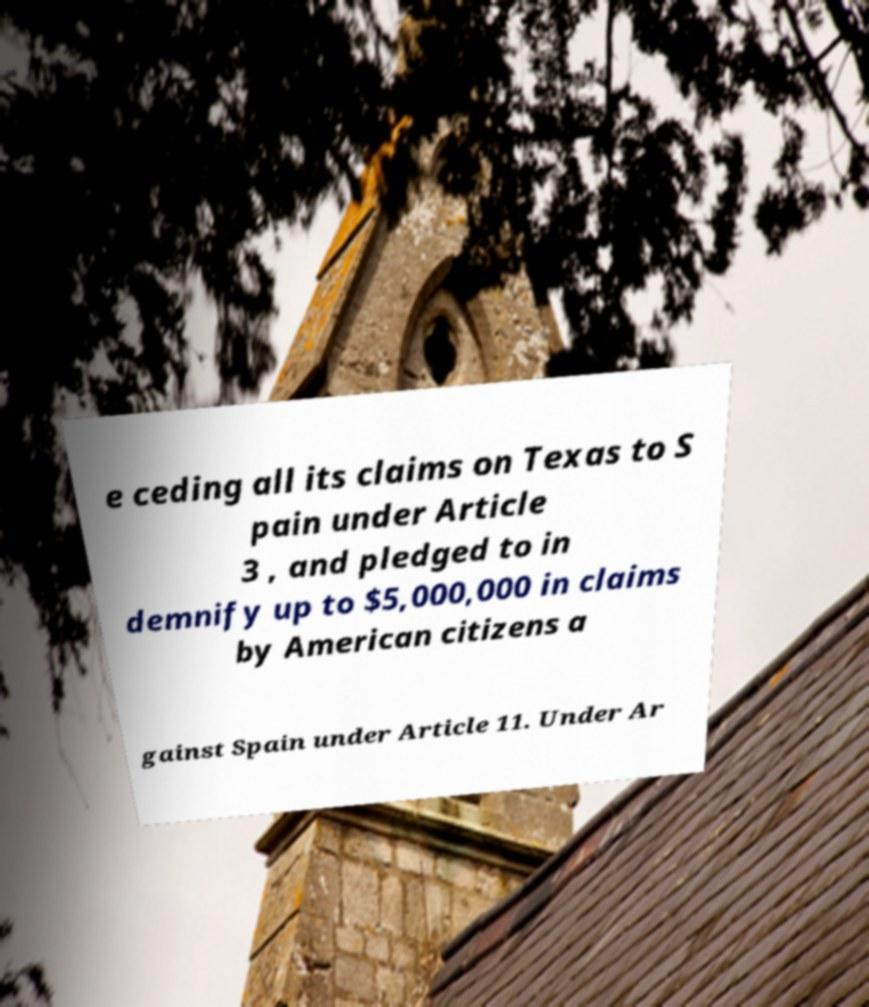For documentation purposes, I need the text within this image transcribed. Could you provide that? e ceding all its claims on Texas to S pain under Article 3 , and pledged to in demnify up to $5,000,000 in claims by American citizens a gainst Spain under Article 11. Under Ar 